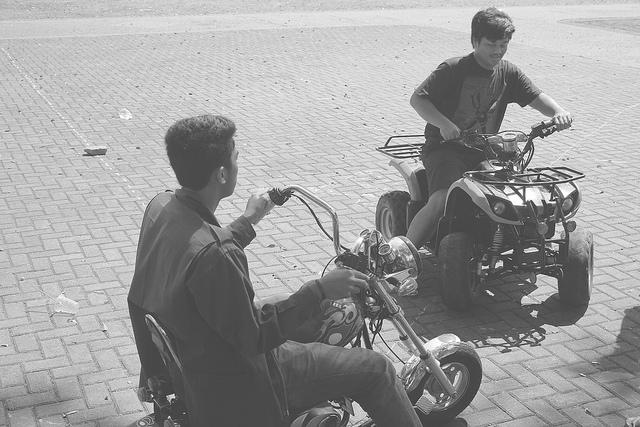Where are these men riding? Please explain your reasoning. street. The area the men are riding on is flat and paved with bricks. there are no hills, trees, sand, or water visible. 